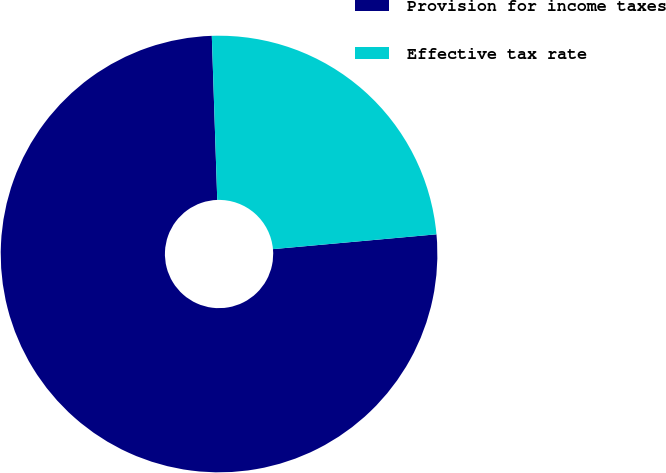<chart> <loc_0><loc_0><loc_500><loc_500><pie_chart><fcel>Provision for income taxes<fcel>Effective tax rate<nl><fcel>75.91%<fcel>24.09%<nl></chart> 